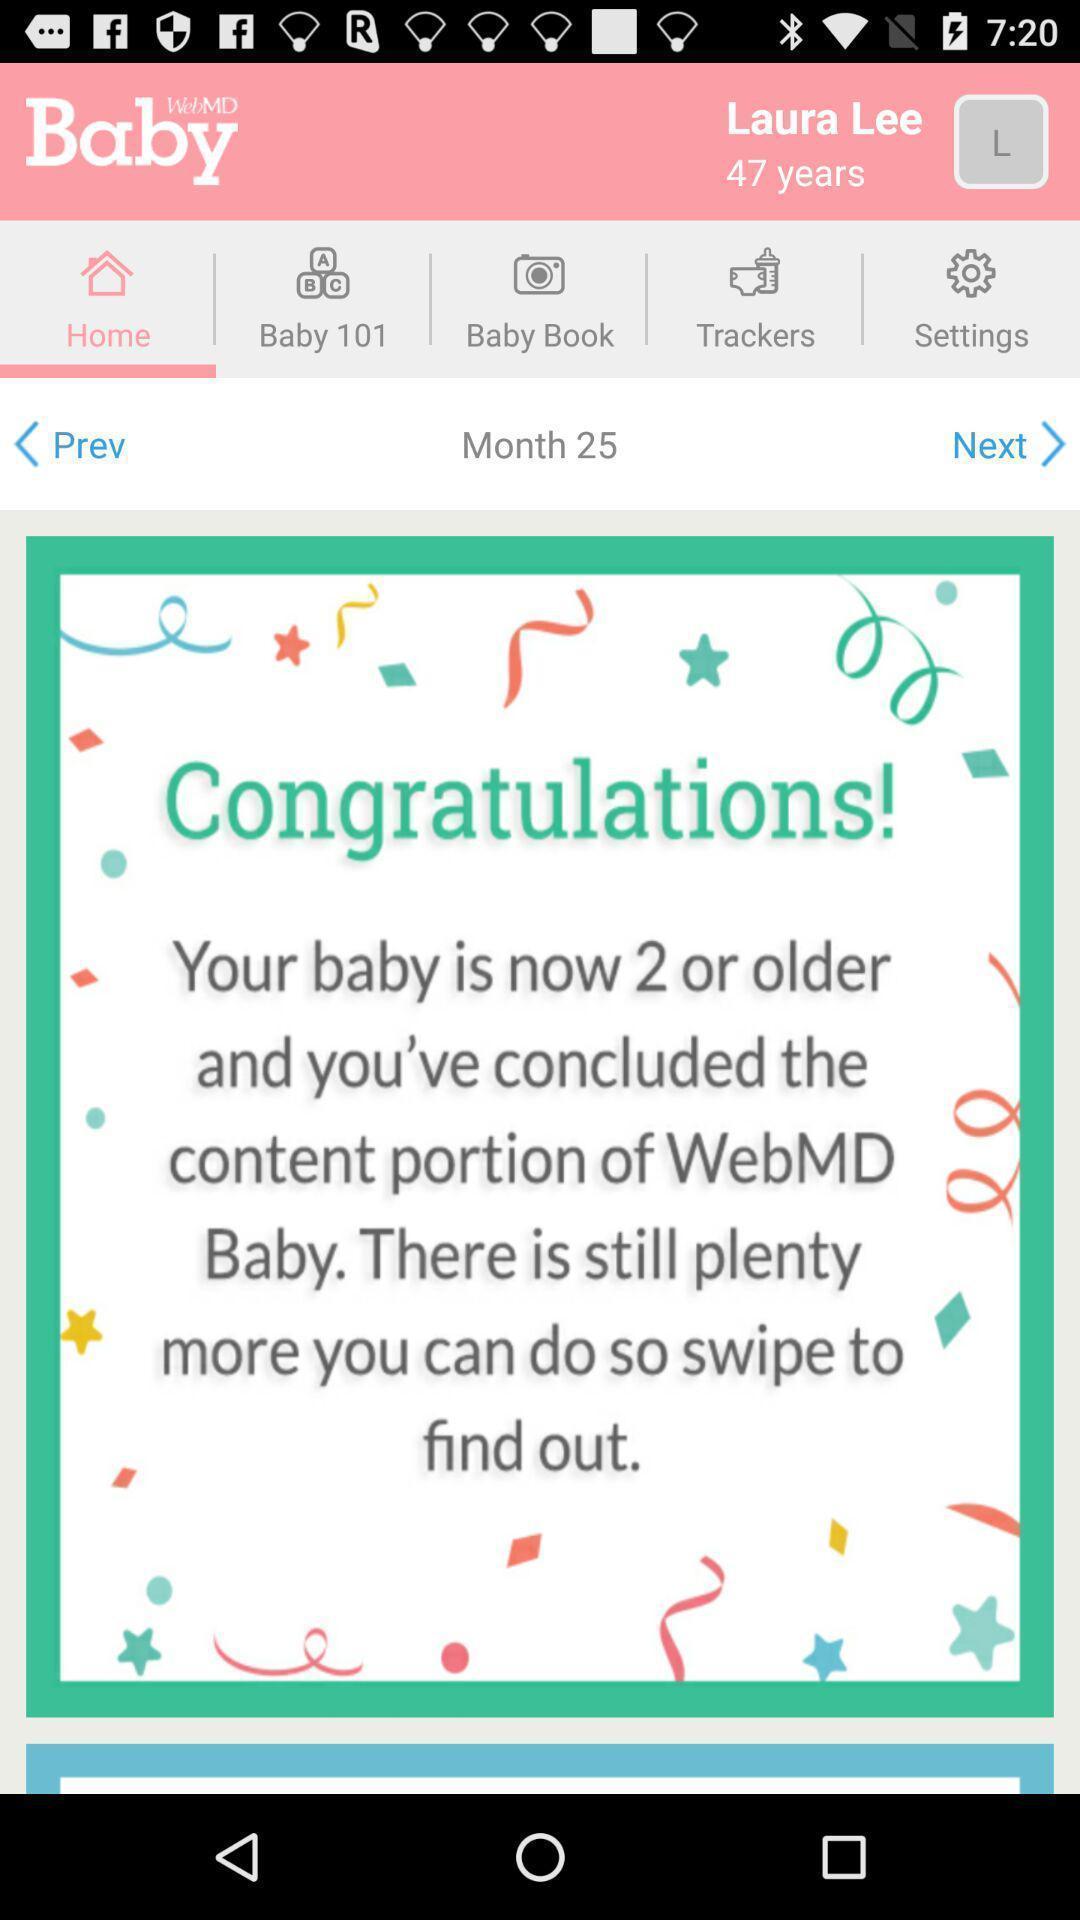Give me a summary of this screen capture. Screen displaying message in home page of baby care app. 